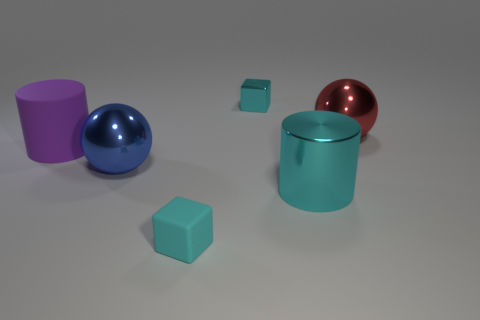Add 2 big shiny cubes. How many objects exist? 8 Subtract all balls. How many objects are left? 4 Subtract 0 blue cylinders. How many objects are left? 6 Subtract all large red metallic things. Subtract all big red spheres. How many objects are left? 4 Add 2 cubes. How many cubes are left? 4 Add 5 big matte cylinders. How many big matte cylinders exist? 6 